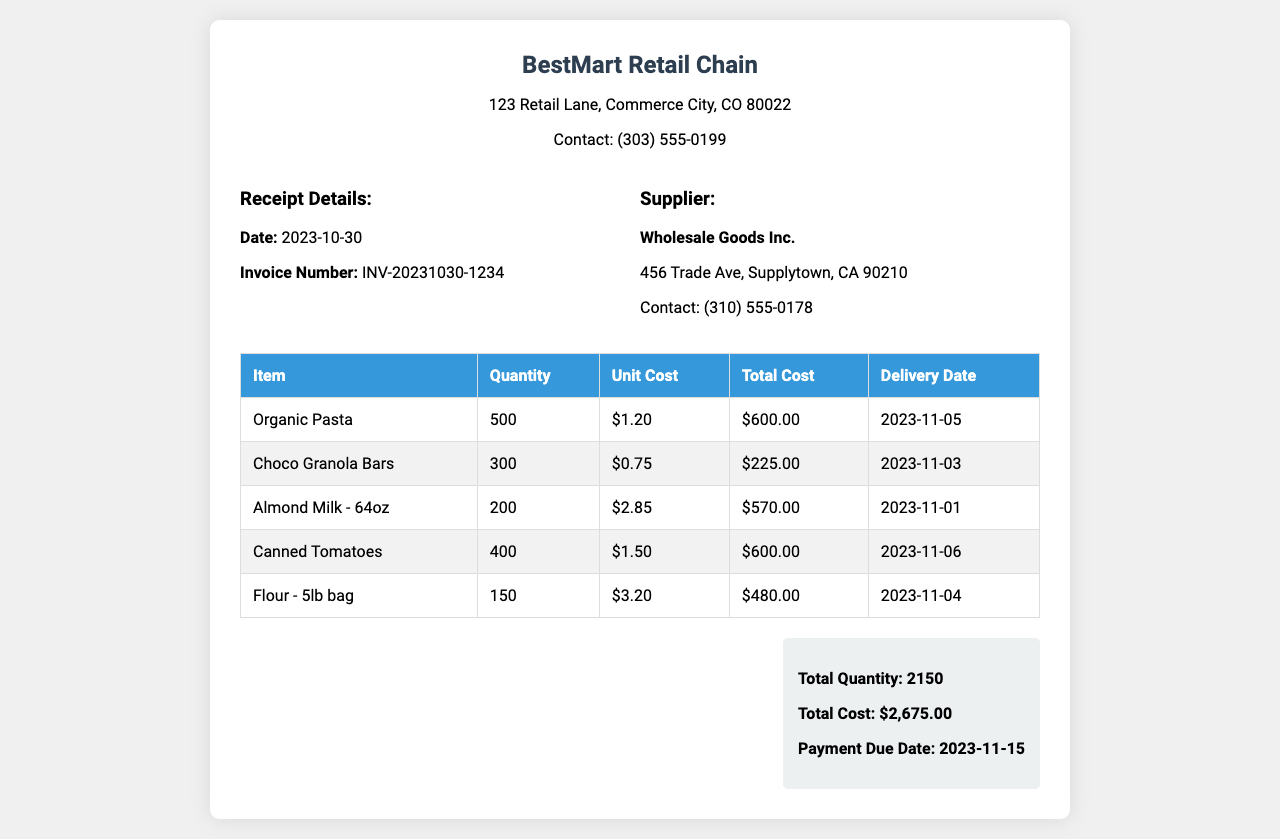What is the total quantity of items ordered? The total quantity is provided in the summary section at the end of the document, which sums the quantities of all items listed.
Answer: 2150 What is the delivery date for Almond Milk? The delivery date for Almond Milk can be found in the table, aligned with the item in question.
Answer: 2023-11-01 Who is the supplier? The supplier is mentioned in the information block, indicating who provided the goods listed on the receipt.
Answer: Wholesale Goods Inc What is the unit cost of Choco Granola Bars? The unit cost for Choco Granola Bars is specified in the table under the “Unit Cost” column.
Answer: $0.75 What is the total cost of the inventory? The total cost is summarized at the end of the document, showing the overall expense for the inventory order.
Answer: $2,675.00 How many Canned Tomatoes were ordered? The number of Canned Tomatoes is indicated in the quantity column of the table for that specific item.
Answer: 400 When is the payment due date? The payment due date is provided in the summary section, indicating when payment for this order must be made.
Answer: 2023-11-15 What is the invoice number? The invoice number is presented in the receipt details at the top of the document, serving as a unique identifier for this transaction.
Answer: INV-20231030-1234 What is the total cost of Organic Pasta? The total cost for Organic Pasta can be calculated by multiplying the quantity by the unit cost but is directly provided in the table.
Answer: $600.00 When is the delivery date for Flour - 5lb bag? The delivery date for the Flour - 5lb bag is listed in the table alongside the item, showing when it will be available.
Answer: 2023-11-04 